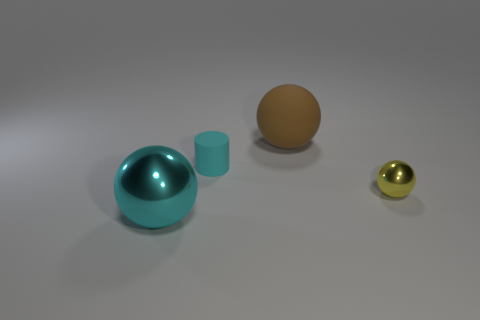How many objects are small shiny balls or small objects that are in front of the cyan rubber cylinder?
Your answer should be compact. 1. What is the shape of the tiny yellow thing?
Offer a very short reply. Sphere. Do the small matte thing and the big shiny ball have the same color?
Provide a short and direct response. Yes. The matte object that is the same size as the cyan shiny sphere is what color?
Provide a succinct answer. Brown. What number of yellow objects are small spheres or spheres?
Make the answer very short. 1. Is the number of tiny gray metal objects greater than the number of big objects?
Your response must be concise. No. There is a brown matte sphere that is on the right side of the tiny cyan rubber cylinder; does it have the same size as the sphere on the left side of the large rubber sphere?
Your response must be concise. Yes. What is the color of the big thing that is right of the shiny ball that is to the left of the small object on the left side of the brown ball?
Your answer should be compact. Brown. Is there a big blue object that has the same shape as the small yellow metal object?
Give a very brief answer. No. Is the number of tiny cyan rubber objects in front of the tiny cylinder greater than the number of big brown cylinders?
Your answer should be very brief. No. 